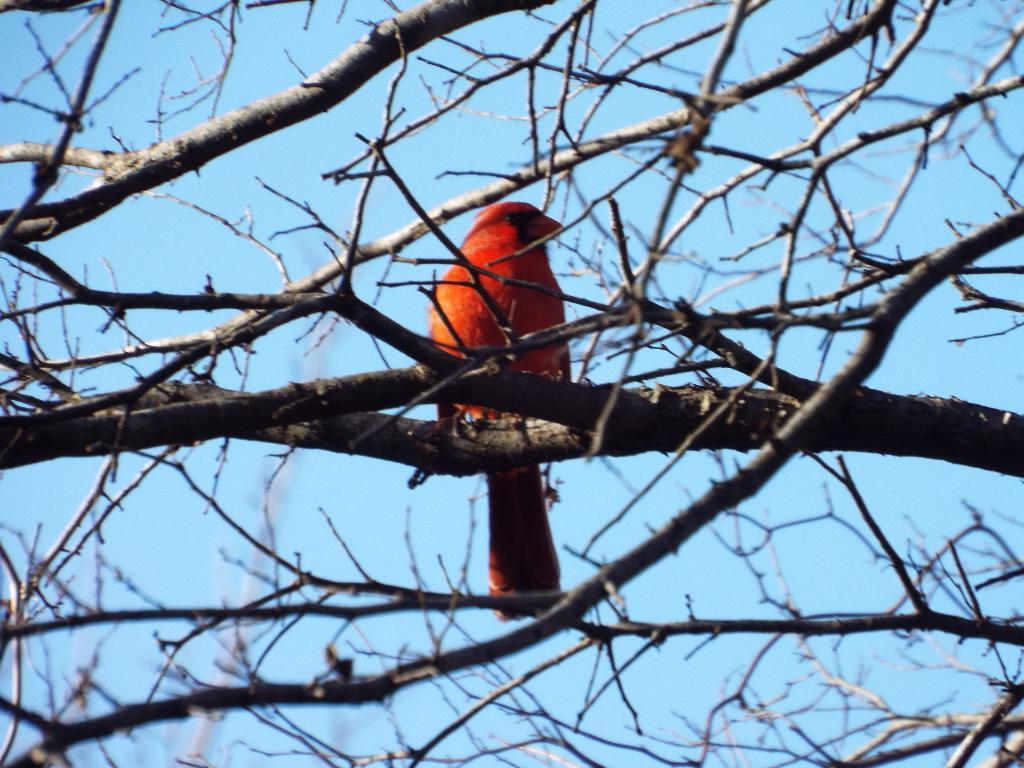What type of animal can be seen in the image? There is a bird in the image. Where is the bird located in the image? The bird is sitting on a branch of a tree. Can you describe the position of the tree branch in the image? The tree branch is in the middle of the image. What can be seen in the background of the image? There is a sky visible in the background of the image. What type of wilderness can be seen in the image? There is no wilderness present in the image; it features a bird sitting on a tree branch with a sky visible in the background. What type of stew is being prepared in the image? There is no stew present in the image; it features a bird sitting on a tree branch with a sky visible in the background. 